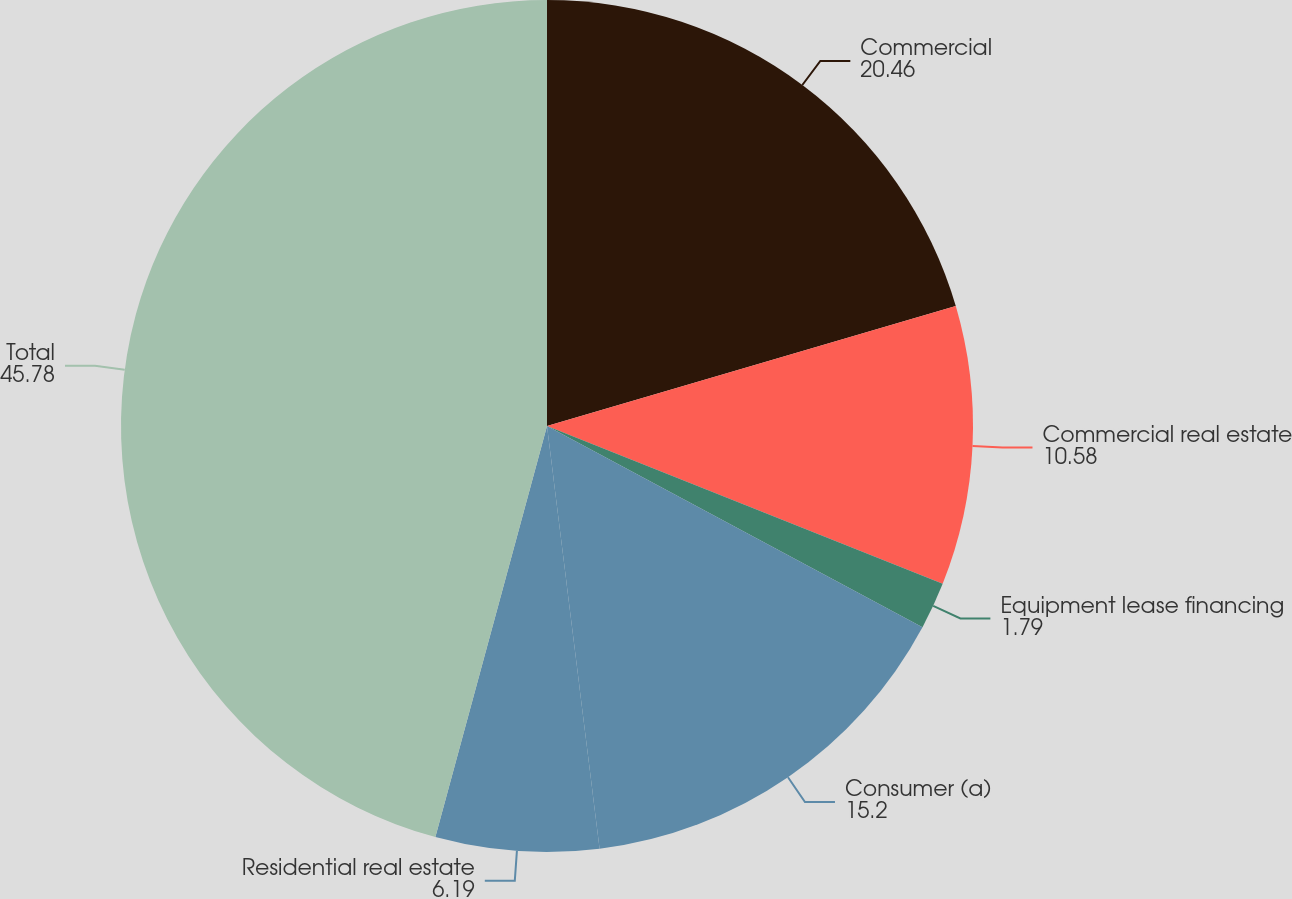Convert chart. <chart><loc_0><loc_0><loc_500><loc_500><pie_chart><fcel>Commercial<fcel>Commercial real estate<fcel>Equipment lease financing<fcel>Consumer (a)<fcel>Residential real estate<fcel>Total<nl><fcel>20.46%<fcel>10.58%<fcel>1.79%<fcel>15.2%<fcel>6.19%<fcel>45.78%<nl></chart> 